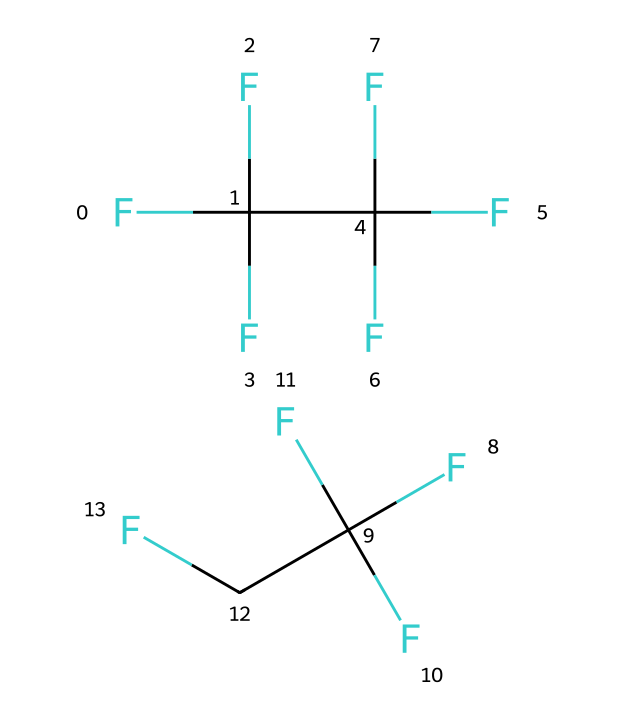How many carbon atoms are in R-410A? The SMILES representation shows the following parts: FC(F)(F)C(F)(F)F and FC(F)(F)CF. Counting the carbon atoms in both parts, we find there are 4 carbon atoms in the first part and 2 in the second part, summing to a total of 4 carbons.
Answer: 4 What is the total number of fluorine atoms in R-410A? The SMILES representation has multiple occurrences of fluorine (F). In both parts, we can count 6 fluorine atoms in the first part (3 from FC(F)(F)C and 3 from C(F)(F)F) and 5 in the second part (3 from FC(F)(F) and 2 attached to CF), leading to a total of 11 fluorine atoms.
Answer: 11 What type of refrigerant is R-410A? R-410A is categorized as a hydrofluorocarbon (HFC) due to its fluorocarbon structure without chlorine, which makes it an environmentally preferred option among refrigerants.
Answer: hydrofluorocarbon Is R-410A classified as a saturated or unsaturated refrigerant? By analyzing the structure, we see that R-410A only contains single bonds in its carbon framework, indicating it is a saturated refrigerant.
Answer: saturated What does the structure imply about the potential environmental impact of R-410A? The absence of chlorine in the structure indicates that R-410A has a lower potential for ozone depletion compared to other refrigerants that contain chlorine, making it more environmentally friendly.
Answer: lower ozone depletion potential How many unique components does R-410A consist of? The SMILES representation consists of two distinct parts with different arrangements, indicating R-410A is a blend made of both components in equal proportions, totaling 2 unique components.
Answer: 2 